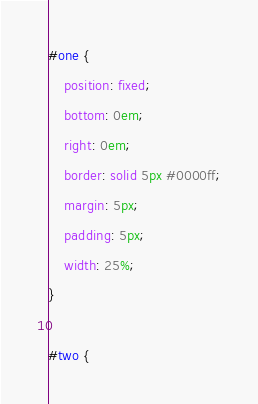<code> <loc_0><loc_0><loc_500><loc_500><_CSS_>#one {
    position: fixed;
    bottom: 0em;
    right: 0em;
    border: solid 5px #0000ff;
    margin: 5px;
    padding: 5px;
    width: 25%;    
}

#two {</code> 